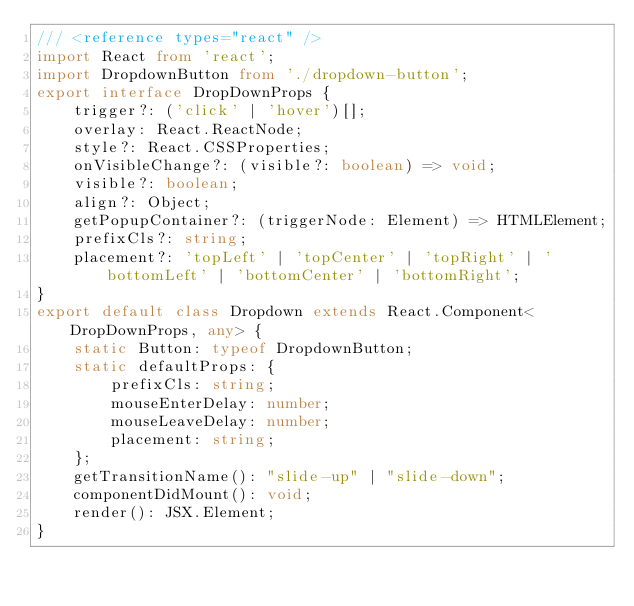<code> <loc_0><loc_0><loc_500><loc_500><_TypeScript_>/// <reference types="react" />
import React from 'react';
import DropdownButton from './dropdown-button';
export interface DropDownProps {
    trigger?: ('click' | 'hover')[];
    overlay: React.ReactNode;
    style?: React.CSSProperties;
    onVisibleChange?: (visible?: boolean) => void;
    visible?: boolean;
    align?: Object;
    getPopupContainer?: (triggerNode: Element) => HTMLElement;
    prefixCls?: string;
    placement?: 'topLeft' | 'topCenter' | 'topRight' | 'bottomLeft' | 'bottomCenter' | 'bottomRight';
}
export default class Dropdown extends React.Component<DropDownProps, any> {
    static Button: typeof DropdownButton;
    static defaultProps: {
        prefixCls: string;
        mouseEnterDelay: number;
        mouseLeaveDelay: number;
        placement: string;
    };
    getTransitionName(): "slide-up" | "slide-down";
    componentDidMount(): void;
    render(): JSX.Element;
}
</code> 